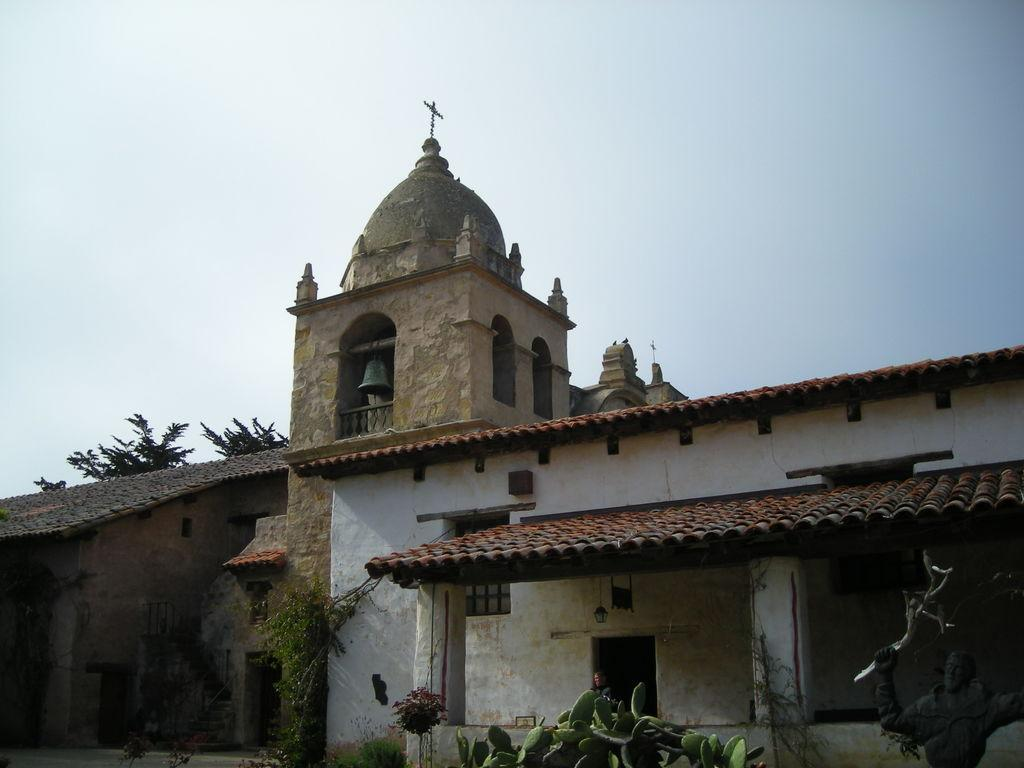What type of structures can be seen in the image? There are buildings in the image. What kind of plant is present in the image? There is a cactus plant in the image. What other types of vegetation can be seen in the image? There are trees and plants in the image. Can you describe any artwork in the image? There is a sculpture in the image. What are the two symbols at the top of the buildings? There are two cross marks at the top of two buildings. Are there any animals visible in the image? Yes, there are two birds in the image. What other object can be seen in the image? There is a bell in the image. What type of scent can be detected from the bun in the image? There is no bun present in the image, so it is not possible to detect any scent. How many bikes are visible in the image? There are no bikes present in the image. 